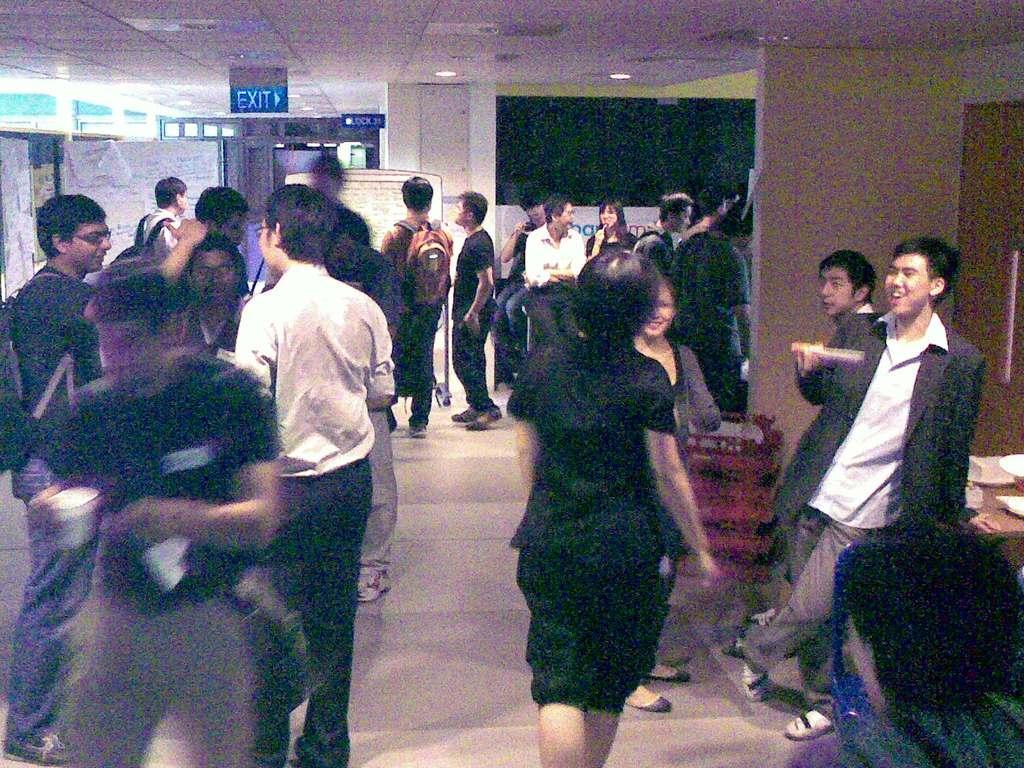Can you describe this image briefly? In this picture I can see number of people who are standing on the floor and I can see the walls. On the top of this picture I can see the ceiling, on which there is a board and I see a word written on it. I can also see the lights. I see that this picture is a bit blurry. 